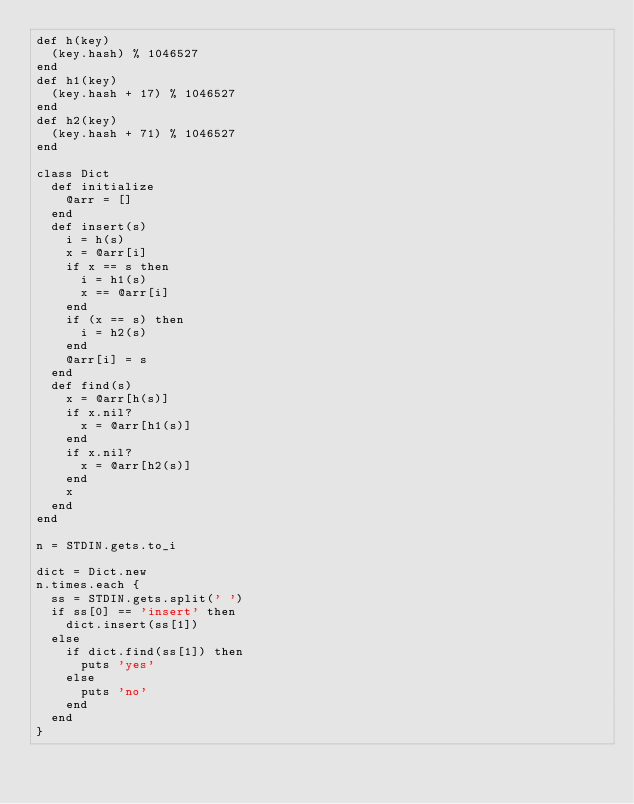Convert code to text. <code><loc_0><loc_0><loc_500><loc_500><_Ruby_>def h(key)
  (key.hash) % 1046527
end
def h1(key)
  (key.hash + 17) % 1046527
end
def h2(key)
  (key.hash + 71) % 1046527
end

class Dict
  def initialize
    @arr = []
  end
  def insert(s)
    i = h(s)
    x = @arr[i]
    if x == s then
      i = h1(s)
      x == @arr[i]
    end
    if (x == s) then
      i = h2(s)
    end
    @arr[i] = s
  end
  def find(s)
    x = @arr[h(s)]
    if x.nil?
      x = @arr[h1(s)]
    end
    if x.nil?
      x = @arr[h2(s)]
    end
    x
  end
end

n = STDIN.gets.to_i

dict = Dict.new
n.times.each {
  ss = STDIN.gets.split(' ')
  if ss[0] == 'insert' then
    dict.insert(ss[1])
  else
    if dict.find(ss[1]) then
      puts 'yes'
    else
      puts 'no'
    end
  end
}</code> 